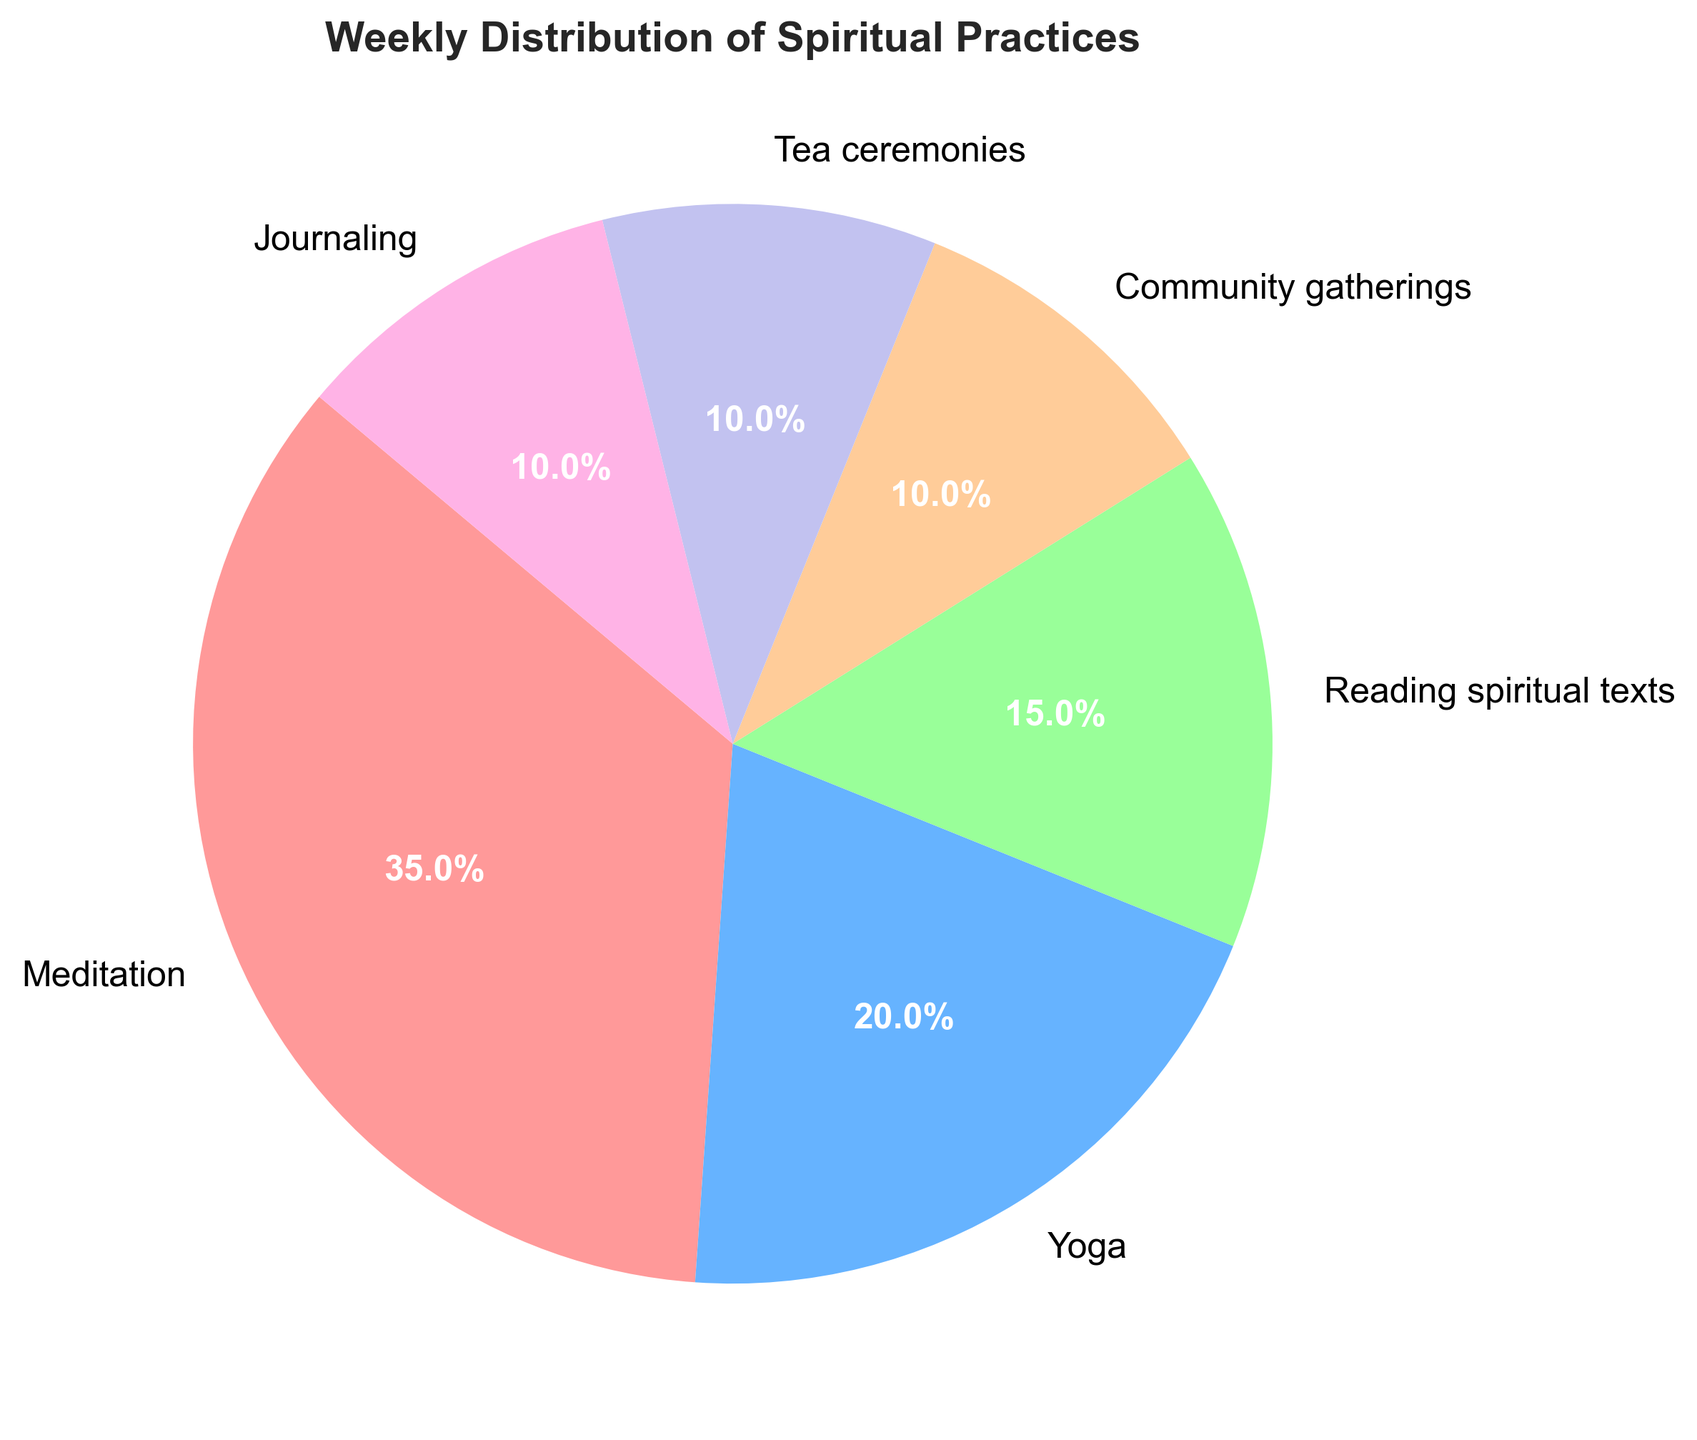What is the most time-consuming spiritual practice according to the chart? The highest value in the pie chart is for Meditation which is labeled 35%, indicating it's the most time-consuming practice.
Answer: Meditation Which spiritual practice takes up the least amount of time? Several practices are tied for the least amount of time spent, each accounting for 10% according to the pie chart. These are Community gatherings, Tea ceremonies, and Journaling.
Answer: Community gatherings, Tea ceremonies, and Journaling What percentage of time is spent on physical activities (Meditation and Yoga combined)? The chart labels Meditation as 35% and Yoga as 20%. Adding these together: 35% + 20% = 55%.
Answer: 55% Compare the time spent on Tea ceremonies with Journaling; is it the same or different? According to the pie chart, both Tea ceremonies and Journaling account for 10% of the time spent on spiritual practices each.
Answer: The same How much more time is spent on Meditation compared to Reading spiritual texts? The pie chart shows Meditation at 35% and Reading spiritual texts at 15%. To find the difference, subtract: 35% - 15% = 20%.
Answer: 20% What is the total percentage of time dedicated to group activities (Community gatherings and Tea ceremonies combined)? The chart indicates Community gatherings at 10% and Tea ceremonies at 10%. Adding these together: 10% + 10% = 20%.
Answer: 20% Among Yoga and Reading spiritual texts, which practice takes up more time? The pie chart shows that Yoga takes up 20% of the time while Reading spiritual texts takes up 15%. Therefore, Yoga takes up more time.
Answer: Yoga Calculate the average percentage of time spent on Tea ceremonies, Community gatherings, and Journaling. According to the chart, each of these practices takes up 10% of the time. The average is calculated by adding them up and dividing by the number of practices: (10% + 10% + 10%) / 3 = 10%.
Answer: 10% Which color represents the practice with the highest percentage of time spent? In the pie chart, the practice with the highest percentage (Meditation) is marked with a shade of red.
Answer: Red 